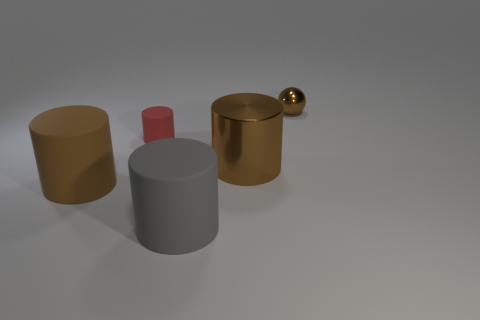Add 5 brown cubes. How many objects exist? 10 Subtract all brown rubber cylinders. How many cylinders are left? 3 Subtract all balls. How many objects are left? 4 Subtract all brown cylinders. How many cylinders are left? 2 Subtract 2 cylinders. How many cylinders are left? 2 Subtract all blue cylinders. Subtract all gray balls. How many cylinders are left? 4 Subtract all brown cubes. How many brown cylinders are left? 2 Subtract all small matte things. Subtract all small brown spheres. How many objects are left? 3 Add 4 big gray objects. How many big gray objects are left? 5 Add 4 small matte objects. How many small matte objects exist? 5 